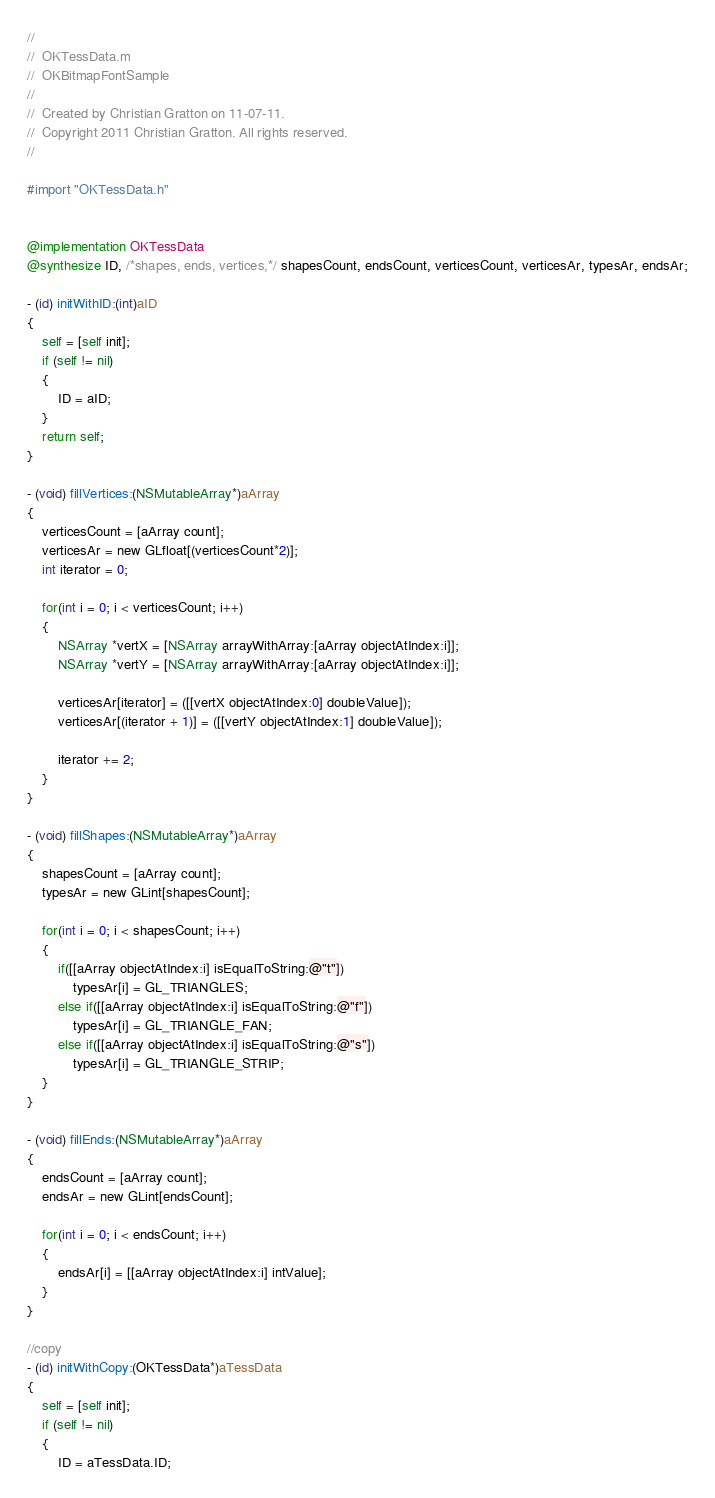<code> <loc_0><loc_0><loc_500><loc_500><_ObjectiveC_>//
//  OKTessData.m
//  OKBitmapFontSample
//
//  Created by Christian Gratton on 11-07-11.
//  Copyright 2011 Christian Gratton. All rights reserved.
//

#import "OKTessData.h"


@implementation OKTessData
@synthesize ID, /*shapes, ends, vertices,*/ shapesCount, endsCount, verticesCount, verticesAr, typesAr, endsAr;

- (id) initWithID:(int)aID
{
    self = [self init];
	if (self != nil)
    {
		ID = aID;
	}
	return self;
}

- (void) fillVertices:(NSMutableArray*)aArray
{
    verticesCount = [aArray count]; 
    verticesAr = new GLfloat[(verticesCount*2)];
    int iterator = 0;
    
    for(int i = 0; i < verticesCount; i++)
    {
        NSArray *vertX = [NSArray arrayWithArray:[aArray objectAtIndex:i]];
        NSArray *vertY = [NSArray arrayWithArray:[aArray objectAtIndex:i]];
        
        verticesAr[iterator] = ([[vertX objectAtIndex:0] doubleValue]);
        verticesAr[(iterator + 1)] = ([[vertY objectAtIndex:1] doubleValue]);
        
        iterator += 2;
    }
}

- (void) fillShapes:(NSMutableArray*)aArray
{
    shapesCount = [aArray count];
    typesAr = new GLint[shapesCount];
    
    for(int i = 0; i < shapesCount; i++)
    {
        if([[aArray objectAtIndex:i] isEqualToString:@"t"])
            typesAr[i] = GL_TRIANGLES;
        else if([[aArray objectAtIndex:i] isEqualToString:@"f"])
            typesAr[i] = GL_TRIANGLE_FAN;
        else if([[aArray objectAtIndex:i] isEqualToString:@"s"])
            typesAr[i] = GL_TRIANGLE_STRIP;
    }
}

- (void) fillEnds:(NSMutableArray*)aArray
{
    endsCount = [aArray count];
    endsAr = new GLint[endsCount];
    
    for(int i = 0; i < endsCount; i++)
    {
        endsAr[i] = [[aArray objectAtIndex:i] intValue];
    }
}

//copy
- (id) initWithCopy:(OKTessData*)aTessData
{
    self = [self init];
	if (self != nil)
    {
		ID = aTessData.ID;</code> 